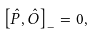<formula> <loc_0><loc_0><loc_500><loc_500>\left [ \hat { P } , \hat { O } \right ] _ { - } = 0 ,</formula> 